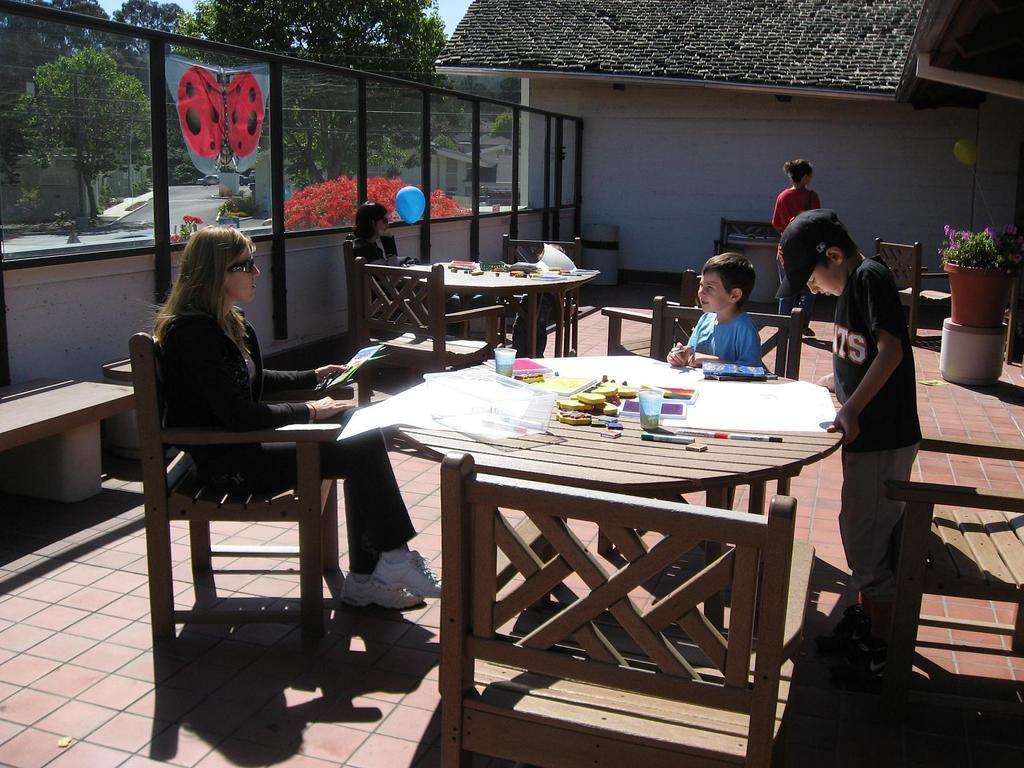How would you summarize this image in a sentence or two? Here we see a woman and a boy seated on a chair and other boy standing and looking at a paper and a woman walking 